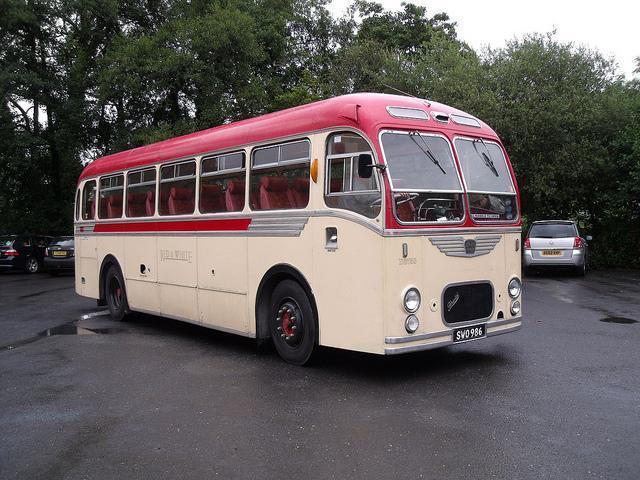How many buses are here?
Give a very brief answer. 1. How many brown horses are jumping in this photo?
Give a very brief answer. 0. 